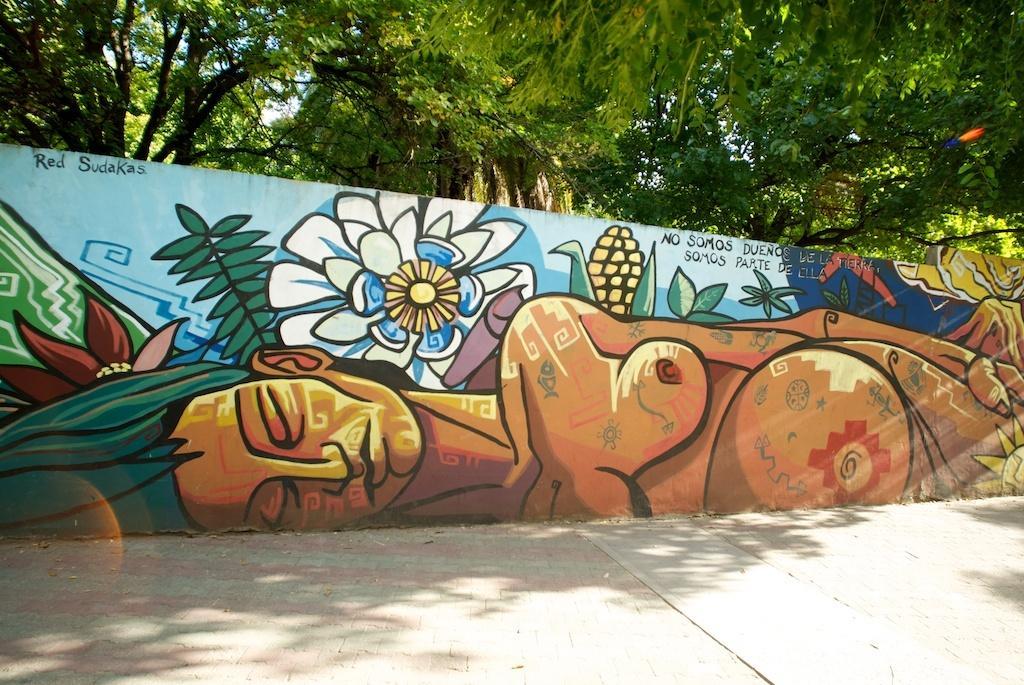Please provide a concise description of this image. In this image we can see a wall with some paintings and text. In the background of the image there are trees and the sky. At the bottom of the image there is the floor. 